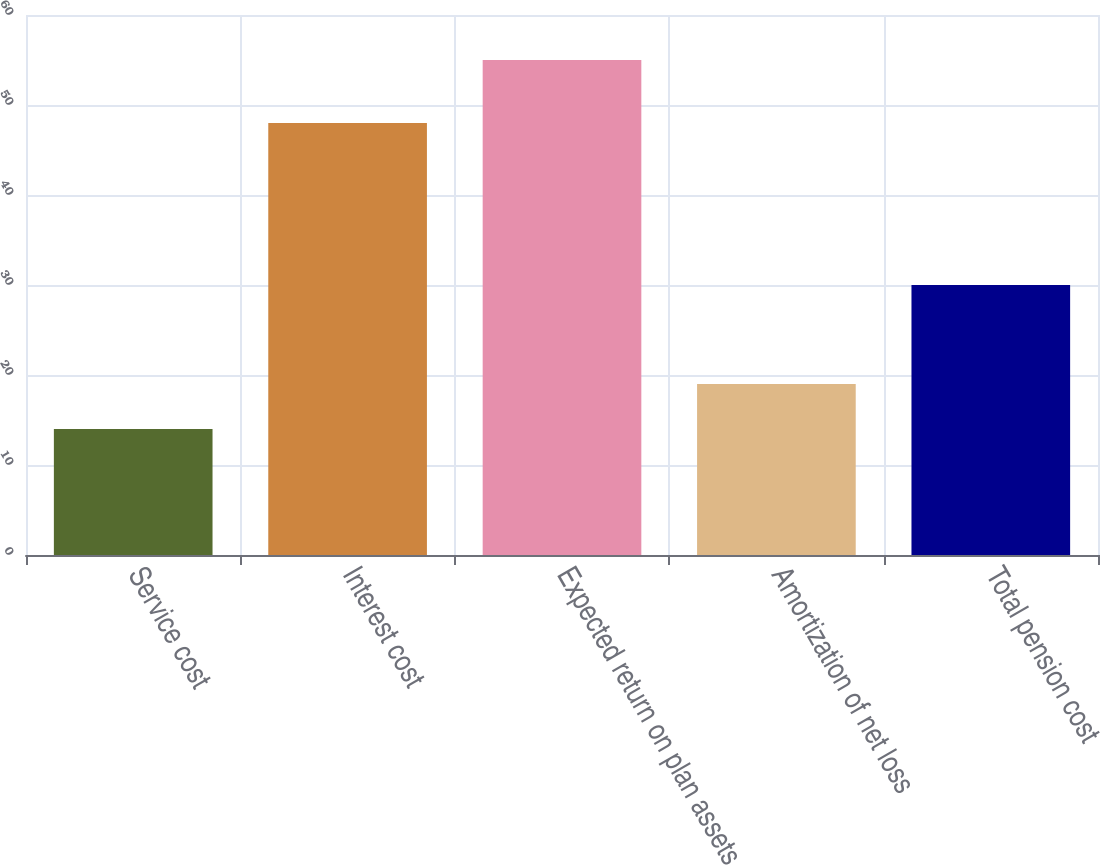Convert chart to OTSL. <chart><loc_0><loc_0><loc_500><loc_500><bar_chart><fcel>Service cost<fcel>Interest cost<fcel>Expected return on plan assets<fcel>Amortization of net loss<fcel>Total pension cost<nl><fcel>14<fcel>48<fcel>55<fcel>19<fcel>30<nl></chart> 